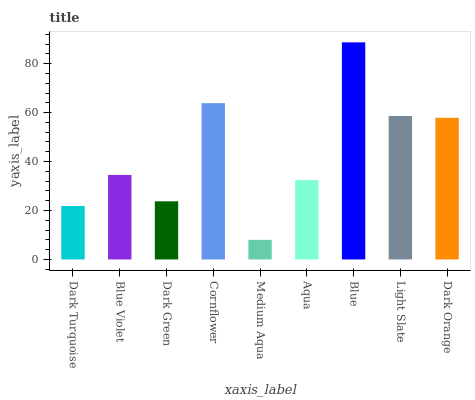Is Medium Aqua the minimum?
Answer yes or no. Yes. Is Blue the maximum?
Answer yes or no. Yes. Is Blue Violet the minimum?
Answer yes or no. No. Is Blue Violet the maximum?
Answer yes or no. No. Is Blue Violet greater than Dark Turquoise?
Answer yes or no. Yes. Is Dark Turquoise less than Blue Violet?
Answer yes or no. Yes. Is Dark Turquoise greater than Blue Violet?
Answer yes or no. No. Is Blue Violet less than Dark Turquoise?
Answer yes or no. No. Is Blue Violet the high median?
Answer yes or no. Yes. Is Blue Violet the low median?
Answer yes or no. Yes. Is Light Slate the high median?
Answer yes or no. No. Is Dark Green the low median?
Answer yes or no. No. 